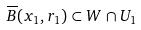<formula> <loc_0><loc_0><loc_500><loc_500>\overline { B } ( x _ { 1 } , r _ { 1 } ) \subset W \cap U _ { 1 }</formula> 